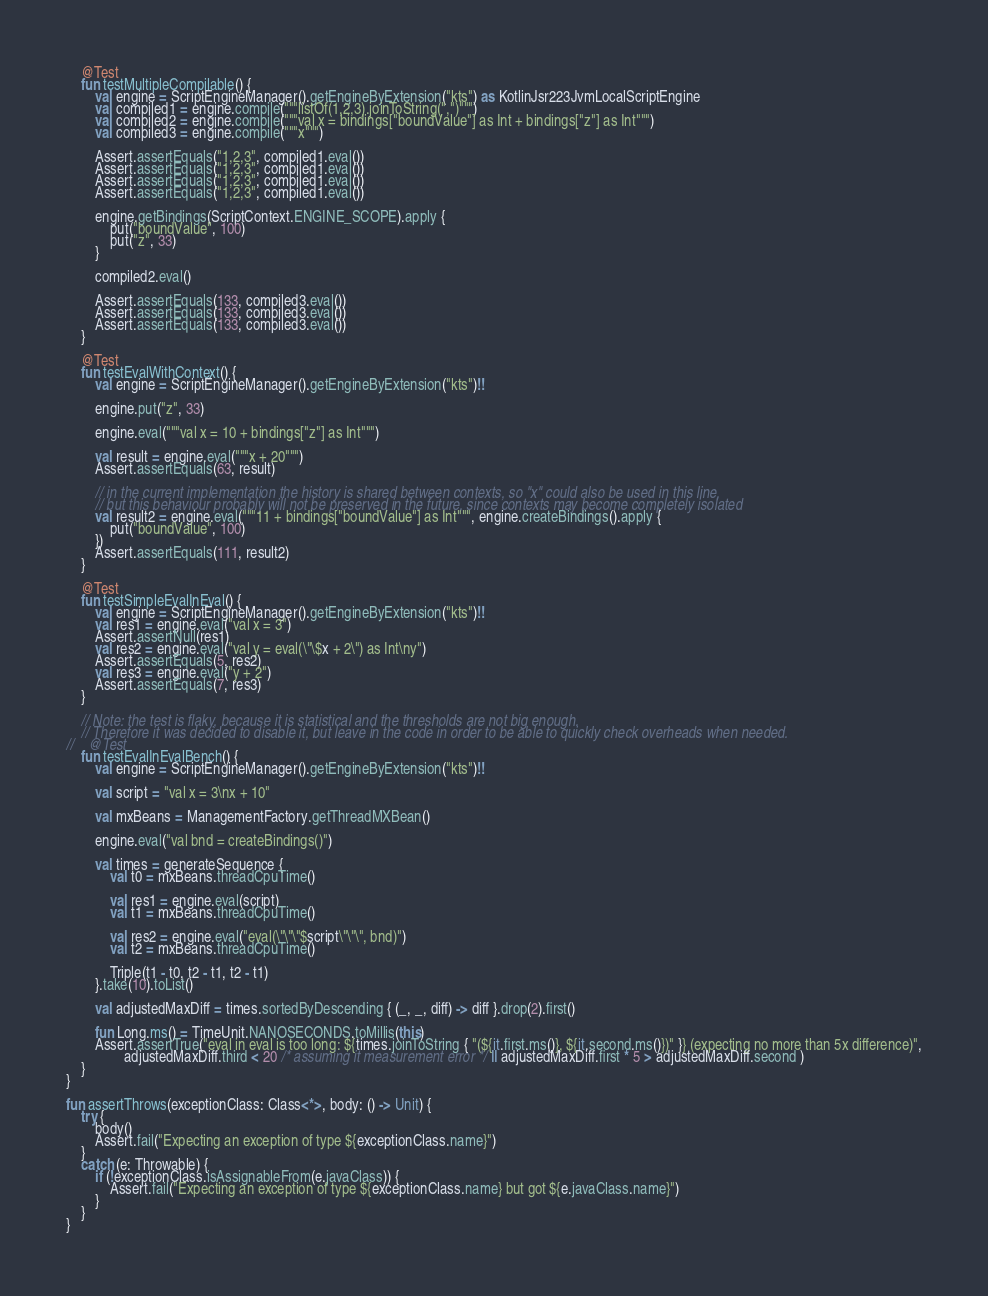Convert code to text. <code><loc_0><loc_0><loc_500><loc_500><_Kotlin_>    @Test
    fun testMultipleCompilable() {
        val engine = ScriptEngineManager().getEngineByExtension("kts") as KotlinJsr223JvmLocalScriptEngine
        val compiled1 = engine.compile("""listOf(1,2,3).joinToString(",")""")
        val compiled2 = engine.compile("""val x = bindings["boundValue"] as Int + bindings["z"] as Int""")
        val compiled3 = engine.compile("""x""")

        Assert.assertEquals("1,2,3", compiled1.eval())
        Assert.assertEquals("1,2,3", compiled1.eval())
        Assert.assertEquals("1,2,3", compiled1.eval())
        Assert.assertEquals("1,2,3", compiled1.eval())

        engine.getBindings(ScriptContext.ENGINE_SCOPE).apply {
            put("boundValue", 100)
            put("z", 33)
        }

        compiled2.eval()

        Assert.assertEquals(133, compiled3.eval())
        Assert.assertEquals(133, compiled3.eval())
        Assert.assertEquals(133, compiled3.eval())
    }

    @Test
    fun testEvalWithContext() {
        val engine = ScriptEngineManager().getEngineByExtension("kts")!!

        engine.put("z", 33)

        engine.eval("""val x = 10 + bindings["z"] as Int""")

        val result = engine.eval("""x + 20""")
        Assert.assertEquals(63, result)

        // in the current implementation the history is shared between contexts, so "x" could also be used in this line,
        // but this behaviour probably will not be preserved in the future, since contexts may become completely isolated
        val result2 = engine.eval("""11 + bindings["boundValue"] as Int""", engine.createBindings().apply {
            put("boundValue", 100)
        })
        Assert.assertEquals(111, result2)
    }

    @Test
    fun testSimpleEvalInEval() {
        val engine = ScriptEngineManager().getEngineByExtension("kts")!!
        val res1 = engine.eval("val x = 3")
        Assert.assertNull(res1)
        val res2 = engine.eval("val y = eval(\"\$x + 2\") as Int\ny")
        Assert.assertEquals(5, res2)
        val res3 = engine.eval("y + 2")
        Assert.assertEquals(7, res3)
    }

    // Note: the test is flaky, because it is statistical and the thresholds are not big enough.
    // Therefore it was decided to disable it, but leave in the code in order to be able to quickly check overheads when needed.
//    @Test
    fun testEvalInEvalBench() {
        val engine = ScriptEngineManager().getEngineByExtension("kts")!!

        val script = "val x = 3\nx + 10"

        val mxBeans = ManagementFactory.getThreadMXBean()

        engine.eval("val bnd = createBindings()")

        val times = generateSequence {
            val t0 = mxBeans.threadCpuTime()

            val res1 = engine.eval(script)
            val t1 = mxBeans.threadCpuTime()

            val res2 = engine.eval("eval(\"\"\"$script\"\"\", bnd)")
            val t2 = mxBeans.threadCpuTime()

            Triple(t1 - t0, t2 - t1, t2 - t1)
        }.take(10).toList()

        val adjustedMaxDiff = times.sortedByDescending { (_, _, diff) -> diff }.drop(2).first()

        fun Long.ms() = TimeUnit.NANOSECONDS.toMillis(this)
        Assert.assertTrue("eval in eval is too long: ${times.joinToString { "(${it.first.ms()}, ${it.second.ms()})" }} (expecting no more than 5x difference)",
                adjustedMaxDiff.third < 20 /* assuming it measurement error */ || adjustedMaxDiff.first * 5 > adjustedMaxDiff.second )
    }
}

fun assertThrows(exceptionClass: Class<*>, body: () -> Unit) {
    try {
        body()
        Assert.fail("Expecting an exception of type ${exceptionClass.name}")
    }
    catch (e: Throwable) {
        if (!exceptionClass.isAssignableFrom(e.javaClass)) {
            Assert.fail("Expecting an exception of type ${exceptionClass.name} but got ${e.javaClass.name}")
        }
    }
}
</code> 